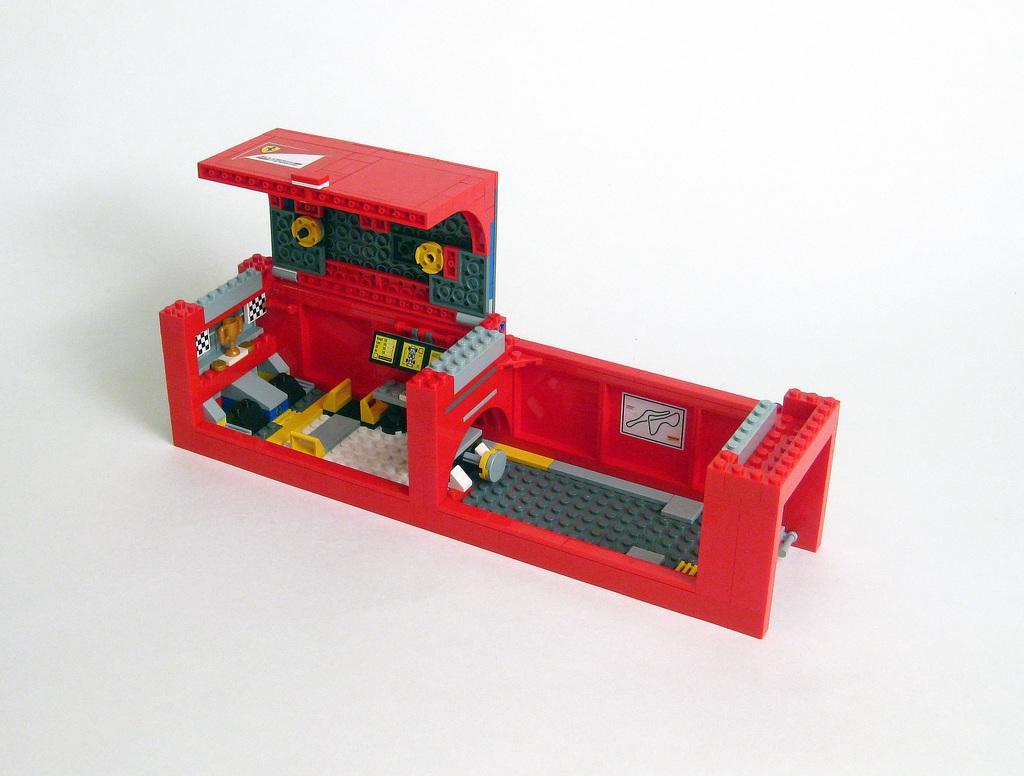Please provide a concise description of this image. In this image I can see a Lego toy on the white colour surface. I can see the colour of the toy is red, green, yellow and grey. 